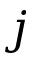Convert formula to latex. <formula><loc_0><loc_0><loc_500><loc_500>j</formula> 